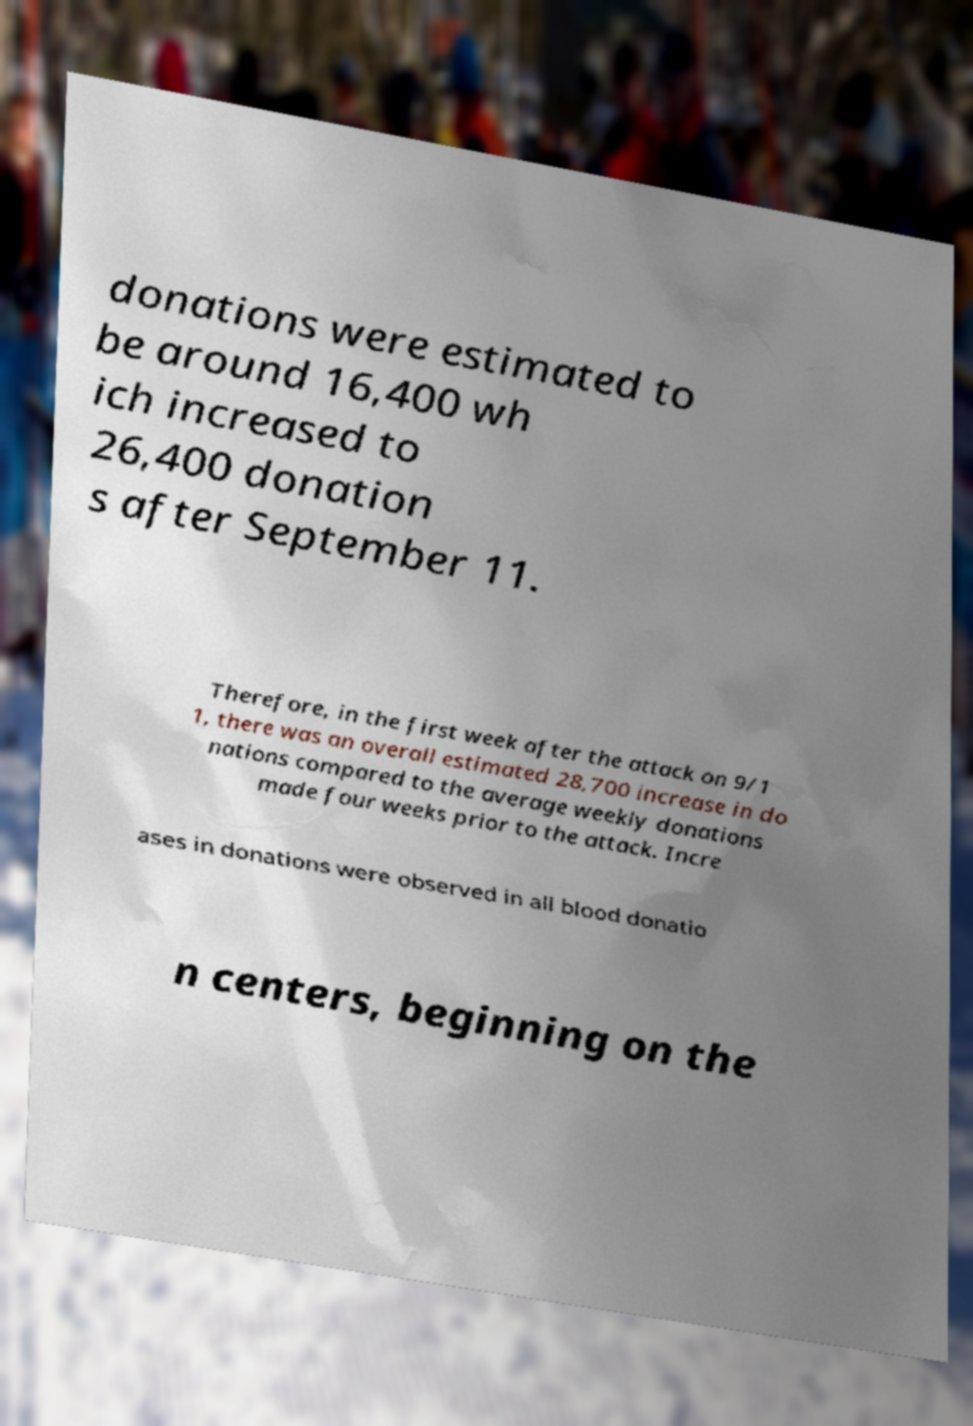There's text embedded in this image that I need extracted. Can you transcribe it verbatim? donations were estimated to be around 16,400 wh ich increased to 26,400 donation s after September 11. Therefore, in the first week after the attack on 9/1 1, there was an overall estimated 28,700 increase in do nations compared to the average weekly donations made four weeks prior to the attack. Incre ases in donations were observed in all blood donatio n centers, beginning on the 